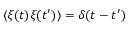<formula> <loc_0><loc_0><loc_500><loc_500>\langle \xi ( t ) \xi ( t ^ { \prime } ) \rangle = \delta ( t - t ^ { \prime } )</formula> 